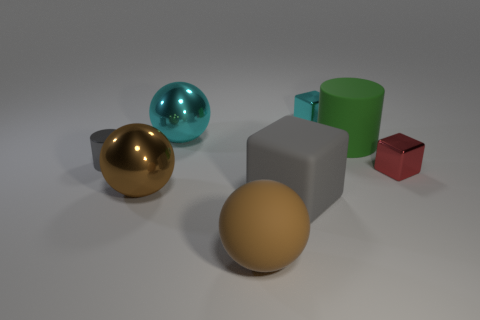Does the cube that is behind the gray cylinder have the same material as the large gray cube?
Your answer should be compact. No. There is a small object that is both in front of the cyan metallic ball and right of the matte cube; what is it made of?
Your response must be concise. Metal. The cube that is the same color as the small metallic cylinder is what size?
Keep it short and to the point. Large. The block behind the tiny object left of the brown metal object is made of what material?
Provide a succinct answer. Metal. How big is the shiny block in front of the gray object behind the metal ball that is left of the big cyan metal sphere?
Provide a short and direct response. Small. What number of small gray cubes are the same material as the small gray cylinder?
Your response must be concise. 0. There is a shiny ball to the left of the sphere that is behind the gray metallic object; what is its color?
Offer a terse response. Brown. What number of things are either brown balls or tiny shiny blocks that are to the right of the large cylinder?
Your response must be concise. 3. Are there any big matte cylinders of the same color as the large rubber block?
Provide a succinct answer. No. How many brown objects are either shiny blocks or large rubber blocks?
Provide a succinct answer. 0. 